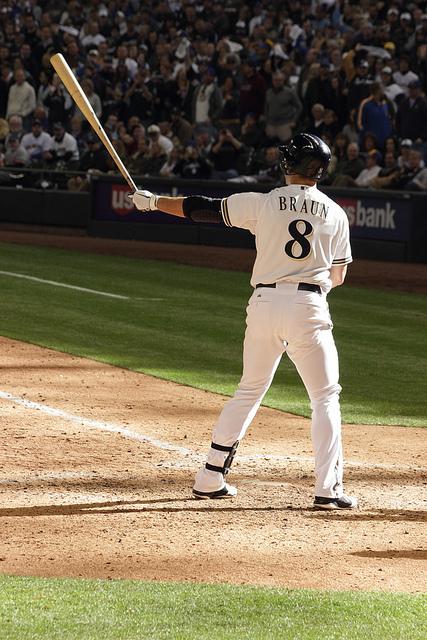Is this a filled stadium?
Quick response, please. Yes. What team is the player playing for?
Give a very brief answer. Yankees. What is his number?
Quick response, please. 8. What leg is the brace on?
Write a very short answer. Left. What is he holding in his left hand?
Be succinct. Bat. 